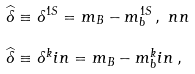<formula> <loc_0><loc_0><loc_500><loc_500>\widehat { \delta } & \equiv \delta ^ { 1 S } = m _ { B } - m _ { b } ^ { 1 S } \, , \ n n \\ \widehat { \delta } & \equiv \delta ^ { k } i n = m _ { B } - m _ { b } ^ { k } i n \, ,</formula> 